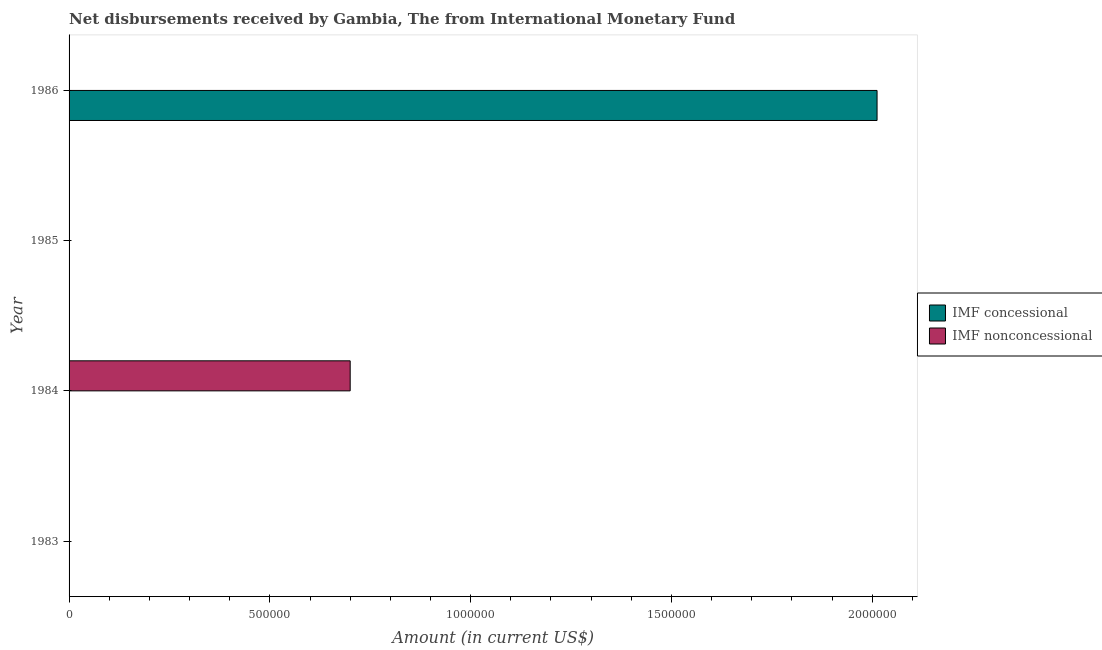Are the number of bars on each tick of the Y-axis equal?
Your answer should be very brief. No. How many bars are there on the 4th tick from the top?
Give a very brief answer. 0. In how many cases, is the number of bars for a given year not equal to the number of legend labels?
Make the answer very short. 4. What is the net concessional disbursements from imf in 1983?
Offer a terse response. 0. Across all years, what is the maximum net non concessional disbursements from imf?
Offer a terse response. 7.00e+05. What is the total net concessional disbursements from imf in the graph?
Provide a succinct answer. 2.01e+06. What is the average net non concessional disbursements from imf per year?
Your response must be concise. 1.75e+05. In how many years, is the net concessional disbursements from imf greater than 1800000 US$?
Offer a terse response. 1. What is the difference between the highest and the lowest net concessional disbursements from imf?
Ensure brevity in your answer.  2.01e+06. In how many years, is the net non concessional disbursements from imf greater than the average net non concessional disbursements from imf taken over all years?
Your response must be concise. 1. How many bars are there?
Give a very brief answer. 2. How many years are there in the graph?
Give a very brief answer. 4. Does the graph contain grids?
Provide a succinct answer. No. Where does the legend appear in the graph?
Keep it short and to the point. Center right. What is the title of the graph?
Your answer should be compact. Net disbursements received by Gambia, The from International Monetary Fund. Does "Health Care" appear as one of the legend labels in the graph?
Make the answer very short. No. What is the Amount (in current US$) in IMF concessional in 1983?
Provide a short and direct response. 0. What is the Amount (in current US$) of IMF concessional in 1984?
Your answer should be compact. 0. What is the Amount (in current US$) in IMF nonconcessional in 1984?
Provide a short and direct response. 7.00e+05. What is the Amount (in current US$) in IMF nonconcessional in 1985?
Your response must be concise. 0. What is the Amount (in current US$) in IMF concessional in 1986?
Ensure brevity in your answer.  2.01e+06. Across all years, what is the maximum Amount (in current US$) in IMF concessional?
Offer a terse response. 2.01e+06. Across all years, what is the maximum Amount (in current US$) of IMF nonconcessional?
Your response must be concise. 7.00e+05. Across all years, what is the minimum Amount (in current US$) of IMF nonconcessional?
Provide a succinct answer. 0. What is the total Amount (in current US$) in IMF concessional in the graph?
Your answer should be compact. 2.01e+06. What is the total Amount (in current US$) in IMF nonconcessional in the graph?
Provide a succinct answer. 7.00e+05. What is the average Amount (in current US$) of IMF concessional per year?
Your response must be concise. 5.03e+05. What is the average Amount (in current US$) of IMF nonconcessional per year?
Make the answer very short. 1.75e+05. What is the difference between the highest and the lowest Amount (in current US$) of IMF concessional?
Your answer should be very brief. 2.01e+06. 